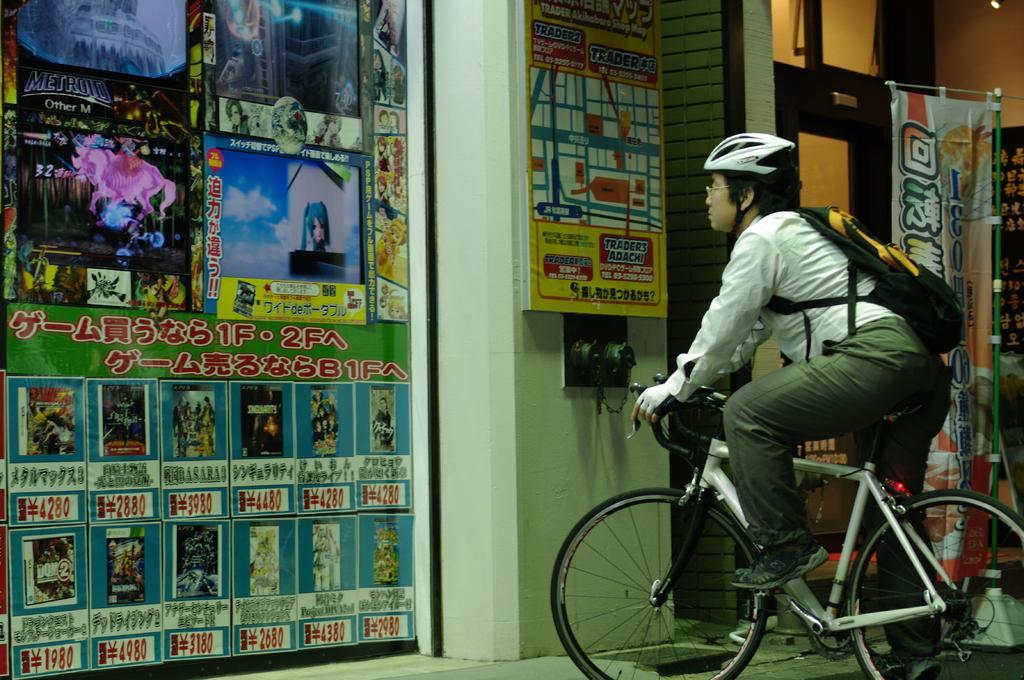In one or two sentences, can you explain what this image depicts? Here we can see a man sitting on a bicycle and he is observing a hoarding which is fixed to a wall. 